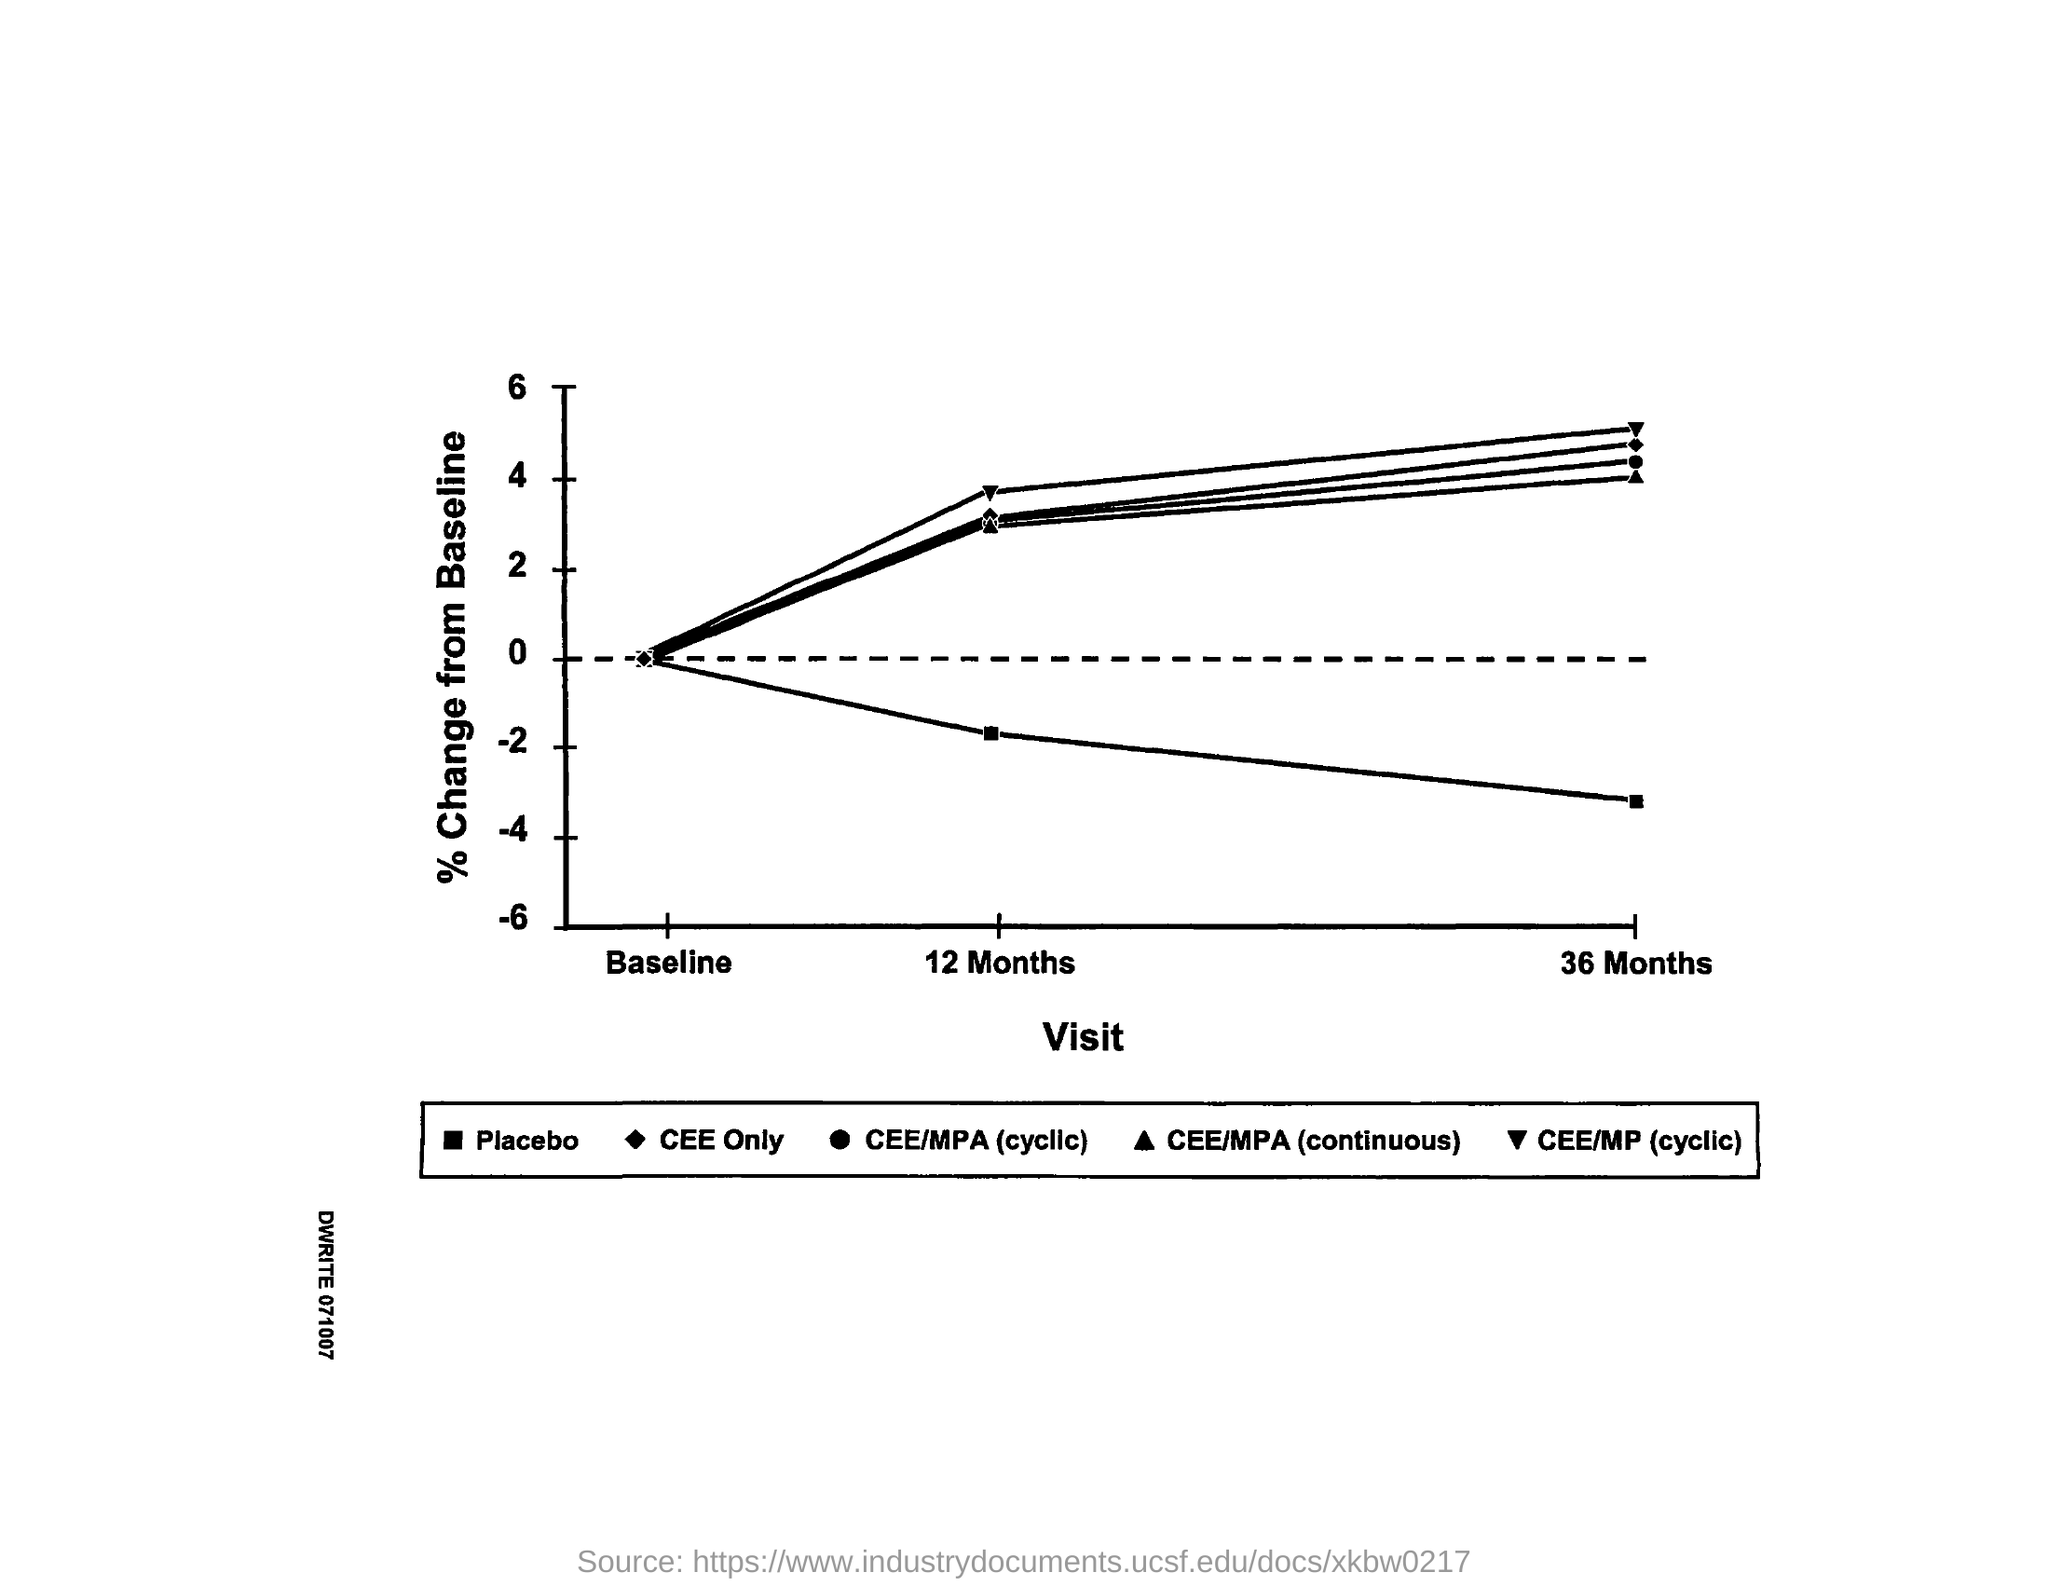What is the X-axis stand for?
Provide a short and direct response. Visit. What is the Y-axis stand for?
Your answer should be compact. % Change from Baseline. 